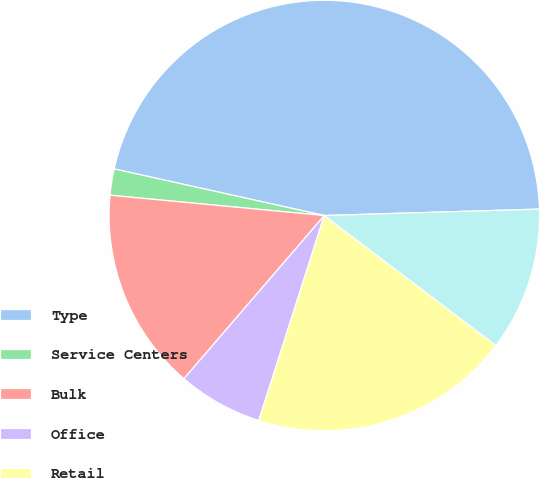Convert chart. <chart><loc_0><loc_0><loc_500><loc_500><pie_chart><fcel>Type<fcel>Service Centers<fcel>Bulk<fcel>Office<fcel>Retail<fcel>Total<nl><fcel>46.05%<fcel>1.97%<fcel>15.2%<fcel>6.38%<fcel>19.61%<fcel>10.79%<nl></chart> 